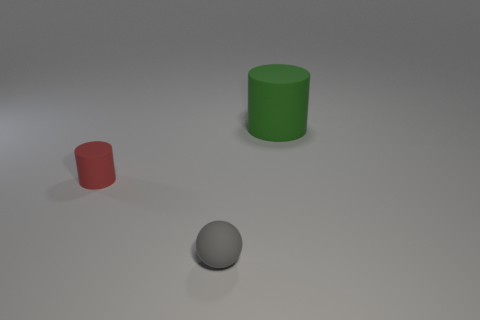The gray matte thing has what shape?
Offer a very short reply. Sphere. What number of small purple things have the same material as the gray ball?
Your answer should be compact. 0. What color is the ball?
Ensure brevity in your answer.  Gray. There is a matte ball that is the same size as the red rubber thing; what color is it?
Keep it short and to the point. Gray. There is a rubber object that is behind the small cylinder; is its shape the same as the object left of the tiny sphere?
Ensure brevity in your answer.  Yes. What number of other things are the same size as the green matte object?
Give a very brief answer. 0. Is the number of green cylinders that are in front of the large green object less than the number of tiny cylinders to the right of the rubber ball?
Keep it short and to the point. No. There is a thing that is behind the gray matte sphere and in front of the big green matte object; what color is it?
Provide a succinct answer. Red. There is a green matte cylinder; is it the same size as the matte thing that is to the left of the tiny gray rubber object?
Provide a short and direct response. No. There is a tiny thing that is to the left of the gray matte ball; what is its shape?
Ensure brevity in your answer.  Cylinder. 